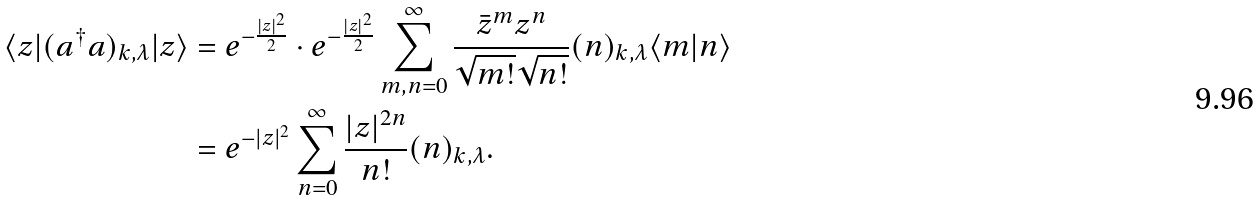Convert formula to latex. <formula><loc_0><loc_0><loc_500><loc_500>\langle z | ( a ^ { \dagger } a ) _ { k , \lambda } | z \rangle & = e ^ { - \frac { | z | ^ { 2 } } { 2 } } \cdot e ^ { - \frac { | z | ^ { 2 } } { 2 } } \sum _ { m , n = 0 } ^ { \infty } \frac { \bar { z } ^ { m } z ^ { n } } { \sqrt { m ! } \sqrt { n ! } } ( n ) _ { k , \lambda } \langle m | n \rangle \\ & = e ^ { - | z | ^ { 2 } } \sum _ { n = 0 } ^ { \infty } \frac { | z | ^ { 2 n } } { n ! } ( n ) _ { k , \lambda } .</formula> 